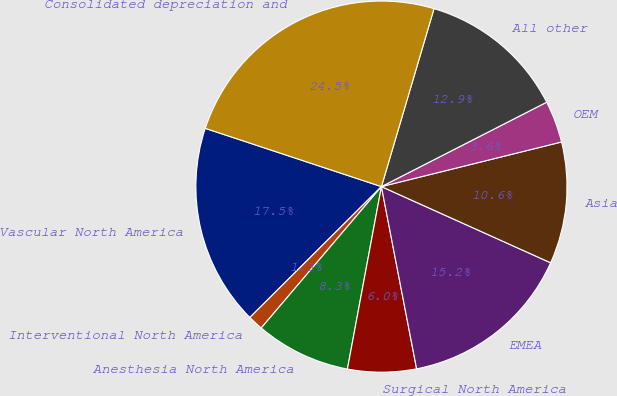<chart> <loc_0><loc_0><loc_500><loc_500><pie_chart><fcel>Vascular North America<fcel>Interventional North America<fcel>Anesthesia North America<fcel>Surgical North America<fcel>EMEA<fcel>Asia<fcel>OEM<fcel>All other<fcel>Consolidated depreciation and<nl><fcel>17.54%<fcel>1.33%<fcel>8.28%<fcel>5.97%<fcel>15.23%<fcel>10.6%<fcel>3.65%<fcel>12.91%<fcel>24.49%<nl></chart> 